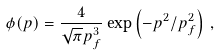<formula> <loc_0><loc_0><loc_500><loc_500>\phi ( p ) = \frac { 4 } { \sqrt { \pi } p _ { f } ^ { 3 } } \exp \left ( - p ^ { 2 } / p _ { f } ^ { 2 } \right ) \, ,</formula> 